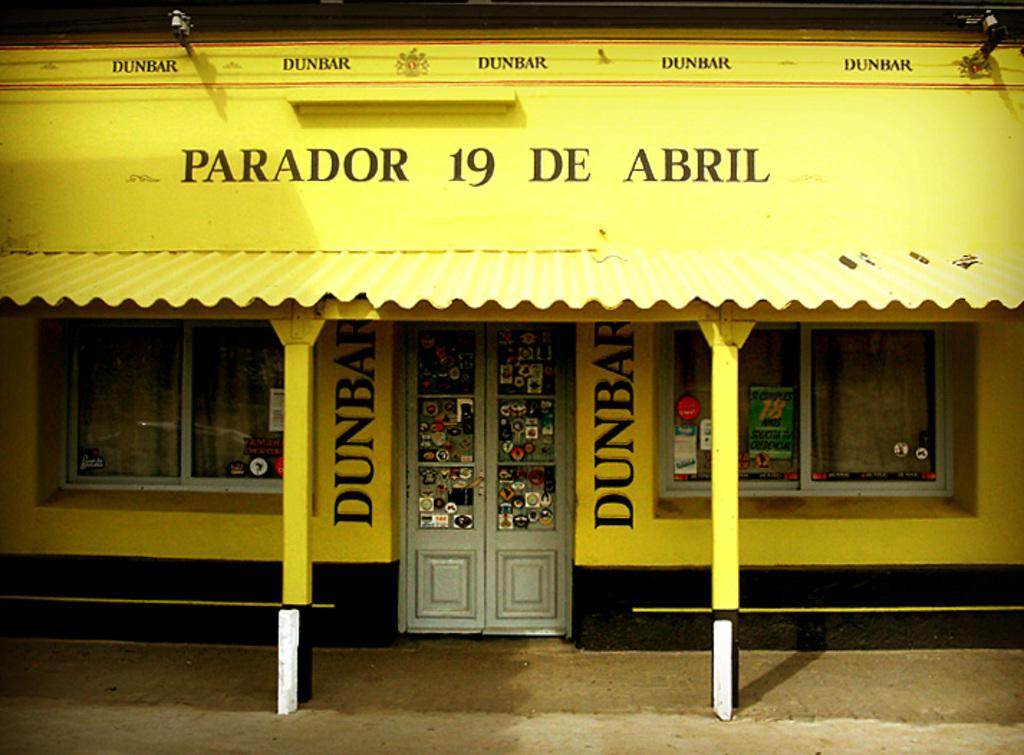What is the main structure visible in the foreground of the image? There is a house in the foreground of the image. What architectural features can be seen in the image? There are pillars in the image. What openings are present in the house? There are windows and a door in the image. Is there any text present in the image? Yes, there is text in the image. Can you describe the lighting conditions in the image? The image may have been taken during the night, as it appears to be dark. What is the rate of the sponge's movement in the image? There is no sponge present in the image, so it is not possible to determine its rate of movement. What route does the text take in the image? The text in the image is stationary and does not follow a route. 